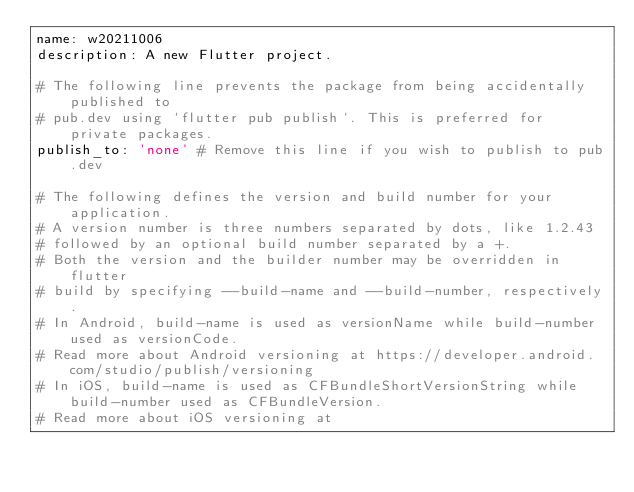Convert code to text. <code><loc_0><loc_0><loc_500><loc_500><_YAML_>name: w20211006
description: A new Flutter project.

# The following line prevents the package from being accidentally published to
# pub.dev using `flutter pub publish`. This is preferred for private packages.
publish_to: 'none' # Remove this line if you wish to publish to pub.dev

# The following defines the version and build number for your application.
# A version number is three numbers separated by dots, like 1.2.43
# followed by an optional build number separated by a +.
# Both the version and the builder number may be overridden in flutter
# build by specifying --build-name and --build-number, respectively.
# In Android, build-name is used as versionName while build-number used as versionCode.
# Read more about Android versioning at https://developer.android.com/studio/publish/versioning
# In iOS, build-name is used as CFBundleShortVersionString while build-number used as CFBundleVersion.
# Read more about iOS versioning at</code> 